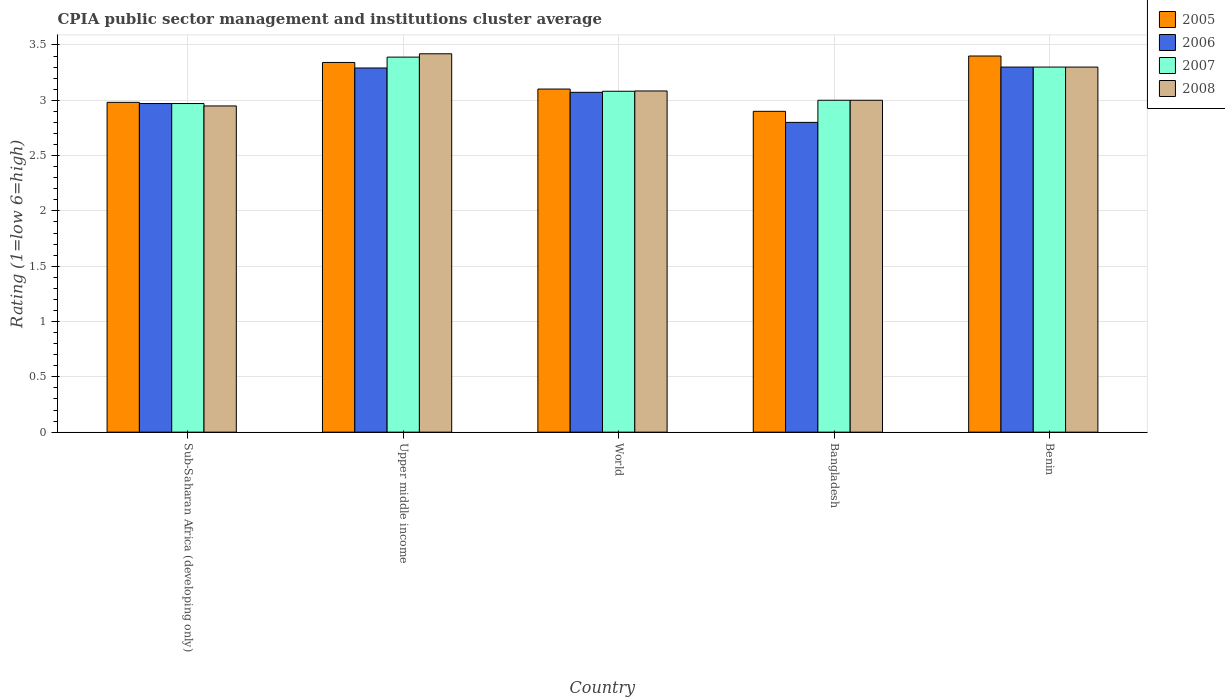How many different coloured bars are there?
Your response must be concise. 4. How many groups of bars are there?
Provide a short and direct response. 5. How many bars are there on the 3rd tick from the right?
Offer a terse response. 4. What is the label of the 5th group of bars from the left?
Offer a terse response. Benin. What is the CPIA rating in 2007 in Upper middle income?
Offer a terse response. 3.39. Across all countries, what is the minimum CPIA rating in 2007?
Ensure brevity in your answer.  2.97. In which country was the CPIA rating in 2005 maximum?
Provide a short and direct response. Benin. In which country was the CPIA rating in 2008 minimum?
Provide a short and direct response. Sub-Saharan Africa (developing only). What is the total CPIA rating in 2007 in the graph?
Provide a succinct answer. 15.74. What is the difference between the CPIA rating in 2006 in Benin and that in World?
Make the answer very short. 0.23. What is the difference between the CPIA rating in 2007 in World and the CPIA rating in 2005 in Benin?
Provide a short and direct response. -0.32. What is the average CPIA rating in 2006 per country?
Keep it short and to the point. 3.09. What is the difference between the CPIA rating of/in 2006 and CPIA rating of/in 2008 in Benin?
Provide a short and direct response. 0. In how many countries, is the CPIA rating in 2006 greater than 0.6?
Keep it short and to the point. 5. What is the ratio of the CPIA rating in 2006 in Benin to that in Sub-Saharan Africa (developing only)?
Provide a succinct answer. 1.11. What is the difference between the highest and the second highest CPIA rating in 2006?
Give a very brief answer. -0.01. Is it the case that in every country, the sum of the CPIA rating in 2005 and CPIA rating in 2007 is greater than the sum of CPIA rating in 2008 and CPIA rating in 2006?
Your response must be concise. No. What does the 2nd bar from the right in Sub-Saharan Africa (developing only) represents?
Provide a succinct answer. 2007. Is it the case that in every country, the sum of the CPIA rating in 2007 and CPIA rating in 2008 is greater than the CPIA rating in 2005?
Provide a succinct answer. Yes. How many countries are there in the graph?
Give a very brief answer. 5. Does the graph contain any zero values?
Your answer should be compact. No. Where does the legend appear in the graph?
Give a very brief answer. Top right. How many legend labels are there?
Your response must be concise. 4. What is the title of the graph?
Your answer should be compact. CPIA public sector management and institutions cluster average. Does "1997" appear as one of the legend labels in the graph?
Your answer should be very brief. No. What is the label or title of the Y-axis?
Keep it short and to the point. Rating (1=low 6=high). What is the Rating (1=low 6=high) in 2005 in Sub-Saharan Africa (developing only)?
Your response must be concise. 2.98. What is the Rating (1=low 6=high) in 2006 in Sub-Saharan Africa (developing only)?
Your response must be concise. 2.97. What is the Rating (1=low 6=high) in 2007 in Sub-Saharan Africa (developing only)?
Your response must be concise. 2.97. What is the Rating (1=low 6=high) of 2008 in Sub-Saharan Africa (developing only)?
Keep it short and to the point. 2.95. What is the Rating (1=low 6=high) in 2005 in Upper middle income?
Offer a terse response. 3.34. What is the Rating (1=low 6=high) of 2006 in Upper middle income?
Give a very brief answer. 3.29. What is the Rating (1=low 6=high) of 2007 in Upper middle income?
Offer a terse response. 3.39. What is the Rating (1=low 6=high) in 2008 in Upper middle income?
Your response must be concise. 3.42. What is the Rating (1=low 6=high) of 2005 in World?
Offer a terse response. 3.1. What is the Rating (1=low 6=high) of 2006 in World?
Offer a terse response. 3.07. What is the Rating (1=low 6=high) in 2007 in World?
Give a very brief answer. 3.08. What is the Rating (1=low 6=high) of 2008 in World?
Offer a terse response. 3.08. What is the Rating (1=low 6=high) in 2005 in Bangladesh?
Provide a succinct answer. 2.9. What is the Rating (1=low 6=high) in 2005 in Benin?
Ensure brevity in your answer.  3.4. What is the Rating (1=low 6=high) in 2008 in Benin?
Your response must be concise. 3.3. Across all countries, what is the maximum Rating (1=low 6=high) of 2007?
Your answer should be very brief. 3.39. Across all countries, what is the maximum Rating (1=low 6=high) of 2008?
Give a very brief answer. 3.42. Across all countries, what is the minimum Rating (1=low 6=high) of 2005?
Offer a very short reply. 2.9. Across all countries, what is the minimum Rating (1=low 6=high) of 2006?
Your answer should be compact. 2.8. Across all countries, what is the minimum Rating (1=low 6=high) of 2007?
Ensure brevity in your answer.  2.97. Across all countries, what is the minimum Rating (1=low 6=high) in 2008?
Make the answer very short. 2.95. What is the total Rating (1=low 6=high) in 2005 in the graph?
Your answer should be compact. 15.72. What is the total Rating (1=low 6=high) of 2006 in the graph?
Provide a succinct answer. 15.43. What is the total Rating (1=low 6=high) of 2007 in the graph?
Keep it short and to the point. 15.74. What is the total Rating (1=low 6=high) of 2008 in the graph?
Keep it short and to the point. 15.75. What is the difference between the Rating (1=low 6=high) of 2005 in Sub-Saharan Africa (developing only) and that in Upper middle income?
Provide a succinct answer. -0.36. What is the difference between the Rating (1=low 6=high) in 2006 in Sub-Saharan Africa (developing only) and that in Upper middle income?
Make the answer very short. -0.32. What is the difference between the Rating (1=low 6=high) in 2007 in Sub-Saharan Africa (developing only) and that in Upper middle income?
Your response must be concise. -0.42. What is the difference between the Rating (1=low 6=high) of 2008 in Sub-Saharan Africa (developing only) and that in Upper middle income?
Keep it short and to the point. -0.47. What is the difference between the Rating (1=low 6=high) in 2005 in Sub-Saharan Africa (developing only) and that in World?
Your answer should be compact. -0.12. What is the difference between the Rating (1=low 6=high) in 2006 in Sub-Saharan Africa (developing only) and that in World?
Offer a very short reply. -0.1. What is the difference between the Rating (1=low 6=high) in 2007 in Sub-Saharan Africa (developing only) and that in World?
Offer a terse response. -0.11. What is the difference between the Rating (1=low 6=high) in 2008 in Sub-Saharan Africa (developing only) and that in World?
Your answer should be compact. -0.14. What is the difference between the Rating (1=low 6=high) of 2005 in Sub-Saharan Africa (developing only) and that in Bangladesh?
Offer a very short reply. 0.08. What is the difference between the Rating (1=low 6=high) in 2006 in Sub-Saharan Africa (developing only) and that in Bangladesh?
Provide a short and direct response. 0.17. What is the difference between the Rating (1=low 6=high) of 2007 in Sub-Saharan Africa (developing only) and that in Bangladesh?
Keep it short and to the point. -0.03. What is the difference between the Rating (1=low 6=high) in 2008 in Sub-Saharan Africa (developing only) and that in Bangladesh?
Provide a succinct answer. -0.05. What is the difference between the Rating (1=low 6=high) in 2005 in Sub-Saharan Africa (developing only) and that in Benin?
Your answer should be very brief. -0.42. What is the difference between the Rating (1=low 6=high) of 2006 in Sub-Saharan Africa (developing only) and that in Benin?
Give a very brief answer. -0.33. What is the difference between the Rating (1=low 6=high) in 2007 in Sub-Saharan Africa (developing only) and that in Benin?
Keep it short and to the point. -0.33. What is the difference between the Rating (1=low 6=high) of 2008 in Sub-Saharan Africa (developing only) and that in Benin?
Provide a short and direct response. -0.35. What is the difference between the Rating (1=low 6=high) of 2005 in Upper middle income and that in World?
Make the answer very short. 0.24. What is the difference between the Rating (1=low 6=high) in 2006 in Upper middle income and that in World?
Give a very brief answer. 0.22. What is the difference between the Rating (1=low 6=high) of 2007 in Upper middle income and that in World?
Your answer should be very brief. 0.31. What is the difference between the Rating (1=low 6=high) of 2008 in Upper middle income and that in World?
Offer a very short reply. 0.34. What is the difference between the Rating (1=low 6=high) of 2005 in Upper middle income and that in Bangladesh?
Give a very brief answer. 0.44. What is the difference between the Rating (1=low 6=high) in 2006 in Upper middle income and that in Bangladesh?
Give a very brief answer. 0.49. What is the difference between the Rating (1=low 6=high) of 2007 in Upper middle income and that in Bangladesh?
Ensure brevity in your answer.  0.39. What is the difference between the Rating (1=low 6=high) of 2008 in Upper middle income and that in Bangladesh?
Provide a short and direct response. 0.42. What is the difference between the Rating (1=low 6=high) of 2005 in Upper middle income and that in Benin?
Offer a terse response. -0.06. What is the difference between the Rating (1=low 6=high) of 2006 in Upper middle income and that in Benin?
Your response must be concise. -0.01. What is the difference between the Rating (1=low 6=high) in 2007 in Upper middle income and that in Benin?
Provide a succinct answer. 0.09. What is the difference between the Rating (1=low 6=high) of 2008 in Upper middle income and that in Benin?
Your answer should be compact. 0.12. What is the difference between the Rating (1=low 6=high) in 2005 in World and that in Bangladesh?
Provide a succinct answer. 0.2. What is the difference between the Rating (1=low 6=high) of 2006 in World and that in Bangladesh?
Make the answer very short. 0.27. What is the difference between the Rating (1=low 6=high) in 2007 in World and that in Bangladesh?
Provide a succinct answer. 0.08. What is the difference between the Rating (1=low 6=high) of 2008 in World and that in Bangladesh?
Your answer should be very brief. 0.08. What is the difference between the Rating (1=low 6=high) of 2005 in World and that in Benin?
Ensure brevity in your answer.  -0.3. What is the difference between the Rating (1=low 6=high) in 2006 in World and that in Benin?
Your response must be concise. -0.23. What is the difference between the Rating (1=low 6=high) in 2007 in World and that in Benin?
Offer a very short reply. -0.22. What is the difference between the Rating (1=low 6=high) in 2008 in World and that in Benin?
Your answer should be very brief. -0.22. What is the difference between the Rating (1=low 6=high) in 2006 in Bangladesh and that in Benin?
Make the answer very short. -0.5. What is the difference between the Rating (1=low 6=high) of 2007 in Bangladesh and that in Benin?
Provide a short and direct response. -0.3. What is the difference between the Rating (1=low 6=high) in 2008 in Bangladesh and that in Benin?
Provide a short and direct response. -0.3. What is the difference between the Rating (1=low 6=high) of 2005 in Sub-Saharan Africa (developing only) and the Rating (1=low 6=high) of 2006 in Upper middle income?
Provide a short and direct response. -0.31. What is the difference between the Rating (1=low 6=high) of 2005 in Sub-Saharan Africa (developing only) and the Rating (1=low 6=high) of 2007 in Upper middle income?
Ensure brevity in your answer.  -0.41. What is the difference between the Rating (1=low 6=high) in 2005 in Sub-Saharan Africa (developing only) and the Rating (1=low 6=high) in 2008 in Upper middle income?
Provide a succinct answer. -0.44. What is the difference between the Rating (1=low 6=high) in 2006 in Sub-Saharan Africa (developing only) and the Rating (1=low 6=high) in 2007 in Upper middle income?
Your answer should be very brief. -0.42. What is the difference between the Rating (1=low 6=high) in 2006 in Sub-Saharan Africa (developing only) and the Rating (1=low 6=high) in 2008 in Upper middle income?
Offer a terse response. -0.45. What is the difference between the Rating (1=low 6=high) of 2007 in Sub-Saharan Africa (developing only) and the Rating (1=low 6=high) of 2008 in Upper middle income?
Your answer should be very brief. -0.45. What is the difference between the Rating (1=low 6=high) of 2005 in Sub-Saharan Africa (developing only) and the Rating (1=low 6=high) of 2006 in World?
Keep it short and to the point. -0.09. What is the difference between the Rating (1=low 6=high) in 2005 in Sub-Saharan Africa (developing only) and the Rating (1=low 6=high) in 2007 in World?
Ensure brevity in your answer.  -0.1. What is the difference between the Rating (1=low 6=high) in 2005 in Sub-Saharan Africa (developing only) and the Rating (1=low 6=high) in 2008 in World?
Offer a very short reply. -0.1. What is the difference between the Rating (1=low 6=high) of 2006 in Sub-Saharan Africa (developing only) and the Rating (1=low 6=high) of 2007 in World?
Your answer should be compact. -0.11. What is the difference between the Rating (1=low 6=high) in 2006 in Sub-Saharan Africa (developing only) and the Rating (1=low 6=high) in 2008 in World?
Offer a very short reply. -0.11. What is the difference between the Rating (1=low 6=high) in 2007 in Sub-Saharan Africa (developing only) and the Rating (1=low 6=high) in 2008 in World?
Provide a succinct answer. -0.11. What is the difference between the Rating (1=low 6=high) in 2005 in Sub-Saharan Africa (developing only) and the Rating (1=low 6=high) in 2006 in Bangladesh?
Keep it short and to the point. 0.18. What is the difference between the Rating (1=low 6=high) of 2005 in Sub-Saharan Africa (developing only) and the Rating (1=low 6=high) of 2007 in Bangladesh?
Your answer should be compact. -0.02. What is the difference between the Rating (1=low 6=high) in 2005 in Sub-Saharan Africa (developing only) and the Rating (1=low 6=high) in 2008 in Bangladesh?
Provide a short and direct response. -0.02. What is the difference between the Rating (1=low 6=high) of 2006 in Sub-Saharan Africa (developing only) and the Rating (1=low 6=high) of 2007 in Bangladesh?
Ensure brevity in your answer.  -0.03. What is the difference between the Rating (1=low 6=high) in 2006 in Sub-Saharan Africa (developing only) and the Rating (1=low 6=high) in 2008 in Bangladesh?
Your answer should be compact. -0.03. What is the difference between the Rating (1=low 6=high) of 2007 in Sub-Saharan Africa (developing only) and the Rating (1=low 6=high) of 2008 in Bangladesh?
Your answer should be compact. -0.03. What is the difference between the Rating (1=low 6=high) of 2005 in Sub-Saharan Africa (developing only) and the Rating (1=low 6=high) of 2006 in Benin?
Ensure brevity in your answer.  -0.32. What is the difference between the Rating (1=low 6=high) in 2005 in Sub-Saharan Africa (developing only) and the Rating (1=low 6=high) in 2007 in Benin?
Ensure brevity in your answer.  -0.32. What is the difference between the Rating (1=low 6=high) of 2005 in Sub-Saharan Africa (developing only) and the Rating (1=low 6=high) of 2008 in Benin?
Your answer should be compact. -0.32. What is the difference between the Rating (1=low 6=high) in 2006 in Sub-Saharan Africa (developing only) and the Rating (1=low 6=high) in 2007 in Benin?
Your response must be concise. -0.33. What is the difference between the Rating (1=low 6=high) in 2006 in Sub-Saharan Africa (developing only) and the Rating (1=low 6=high) in 2008 in Benin?
Your answer should be compact. -0.33. What is the difference between the Rating (1=low 6=high) of 2007 in Sub-Saharan Africa (developing only) and the Rating (1=low 6=high) of 2008 in Benin?
Your response must be concise. -0.33. What is the difference between the Rating (1=low 6=high) in 2005 in Upper middle income and the Rating (1=low 6=high) in 2006 in World?
Provide a succinct answer. 0.27. What is the difference between the Rating (1=low 6=high) in 2005 in Upper middle income and the Rating (1=low 6=high) in 2007 in World?
Make the answer very short. 0.26. What is the difference between the Rating (1=low 6=high) in 2005 in Upper middle income and the Rating (1=low 6=high) in 2008 in World?
Offer a very short reply. 0.26. What is the difference between the Rating (1=low 6=high) in 2006 in Upper middle income and the Rating (1=low 6=high) in 2007 in World?
Give a very brief answer. 0.21. What is the difference between the Rating (1=low 6=high) of 2006 in Upper middle income and the Rating (1=low 6=high) of 2008 in World?
Your response must be concise. 0.21. What is the difference between the Rating (1=low 6=high) of 2007 in Upper middle income and the Rating (1=low 6=high) of 2008 in World?
Offer a terse response. 0.31. What is the difference between the Rating (1=low 6=high) of 2005 in Upper middle income and the Rating (1=low 6=high) of 2006 in Bangladesh?
Your answer should be compact. 0.54. What is the difference between the Rating (1=low 6=high) in 2005 in Upper middle income and the Rating (1=low 6=high) in 2007 in Bangladesh?
Ensure brevity in your answer.  0.34. What is the difference between the Rating (1=low 6=high) in 2005 in Upper middle income and the Rating (1=low 6=high) in 2008 in Bangladesh?
Ensure brevity in your answer.  0.34. What is the difference between the Rating (1=low 6=high) in 2006 in Upper middle income and the Rating (1=low 6=high) in 2007 in Bangladesh?
Provide a succinct answer. 0.29. What is the difference between the Rating (1=low 6=high) in 2006 in Upper middle income and the Rating (1=low 6=high) in 2008 in Bangladesh?
Offer a very short reply. 0.29. What is the difference between the Rating (1=low 6=high) of 2007 in Upper middle income and the Rating (1=low 6=high) of 2008 in Bangladesh?
Keep it short and to the point. 0.39. What is the difference between the Rating (1=low 6=high) of 2005 in Upper middle income and the Rating (1=low 6=high) of 2006 in Benin?
Ensure brevity in your answer.  0.04. What is the difference between the Rating (1=low 6=high) in 2005 in Upper middle income and the Rating (1=low 6=high) in 2007 in Benin?
Ensure brevity in your answer.  0.04. What is the difference between the Rating (1=low 6=high) of 2005 in Upper middle income and the Rating (1=low 6=high) of 2008 in Benin?
Make the answer very short. 0.04. What is the difference between the Rating (1=low 6=high) in 2006 in Upper middle income and the Rating (1=low 6=high) in 2007 in Benin?
Ensure brevity in your answer.  -0.01. What is the difference between the Rating (1=low 6=high) in 2006 in Upper middle income and the Rating (1=low 6=high) in 2008 in Benin?
Your response must be concise. -0.01. What is the difference between the Rating (1=low 6=high) in 2007 in Upper middle income and the Rating (1=low 6=high) in 2008 in Benin?
Your answer should be compact. 0.09. What is the difference between the Rating (1=low 6=high) in 2005 in World and the Rating (1=low 6=high) in 2006 in Bangladesh?
Offer a terse response. 0.3. What is the difference between the Rating (1=low 6=high) of 2005 in World and the Rating (1=low 6=high) of 2007 in Bangladesh?
Provide a short and direct response. 0.1. What is the difference between the Rating (1=low 6=high) in 2005 in World and the Rating (1=low 6=high) in 2008 in Bangladesh?
Your response must be concise. 0.1. What is the difference between the Rating (1=low 6=high) in 2006 in World and the Rating (1=low 6=high) in 2007 in Bangladesh?
Your answer should be compact. 0.07. What is the difference between the Rating (1=low 6=high) in 2006 in World and the Rating (1=low 6=high) in 2008 in Bangladesh?
Your answer should be compact. 0.07. What is the difference between the Rating (1=low 6=high) in 2007 in World and the Rating (1=low 6=high) in 2008 in Bangladesh?
Make the answer very short. 0.08. What is the difference between the Rating (1=low 6=high) in 2005 in World and the Rating (1=low 6=high) in 2006 in Benin?
Make the answer very short. -0.2. What is the difference between the Rating (1=low 6=high) in 2005 in World and the Rating (1=low 6=high) in 2007 in Benin?
Your answer should be compact. -0.2. What is the difference between the Rating (1=low 6=high) of 2005 in World and the Rating (1=low 6=high) of 2008 in Benin?
Provide a succinct answer. -0.2. What is the difference between the Rating (1=low 6=high) in 2006 in World and the Rating (1=low 6=high) in 2007 in Benin?
Your response must be concise. -0.23. What is the difference between the Rating (1=low 6=high) in 2006 in World and the Rating (1=low 6=high) in 2008 in Benin?
Keep it short and to the point. -0.23. What is the difference between the Rating (1=low 6=high) of 2007 in World and the Rating (1=low 6=high) of 2008 in Benin?
Offer a terse response. -0.22. What is the difference between the Rating (1=low 6=high) of 2006 in Bangladesh and the Rating (1=low 6=high) of 2007 in Benin?
Offer a very short reply. -0.5. What is the difference between the Rating (1=low 6=high) of 2007 in Bangladesh and the Rating (1=low 6=high) of 2008 in Benin?
Keep it short and to the point. -0.3. What is the average Rating (1=low 6=high) of 2005 per country?
Give a very brief answer. 3.14. What is the average Rating (1=low 6=high) in 2006 per country?
Your response must be concise. 3.09. What is the average Rating (1=low 6=high) in 2007 per country?
Provide a short and direct response. 3.15. What is the average Rating (1=low 6=high) in 2008 per country?
Keep it short and to the point. 3.15. What is the difference between the Rating (1=low 6=high) of 2005 and Rating (1=low 6=high) of 2006 in Sub-Saharan Africa (developing only)?
Provide a succinct answer. 0.01. What is the difference between the Rating (1=low 6=high) in 2005 and Rating (1=low 6=high) in 2007 in Sub-Saharan Africa (developing only)?
Offer a very short reply. 0.01. What is the difference between the Rating (1=low 6=high) of 2005 and Rating (1=low 6=high) of 2008 in Sub-Saharan Africa (developing only)?
Offer a terse response. 0.03. What is the difference between the Rating (1=low 6=high) of 2006 and Rating (1=low 6=high) of 2007 in Sub-Saharan Africa (developing only)?
Make the answer very short. 0. What is the difference between the Rating (1=low 6=high) in 2006 and Rating (1=low 6=high) in 2008 in Sub-Saharan Africa (developing only)?
Your answer should be compact. 0.02. What is the difference between the Rating (1=low 6=high) in 2007 and Rating (1=low 6=high) in 2008 in Sub-Saharan Africa (developing only)?
Give a very brief answer. 0.02. What is the difference between the Rating (1=low 6=high) of 2005 and Rating (1=low 6=high) of 2006 in Upper middle income?
Make the answer very short. 0.05. What is the difference between the Rating (1=low 6=high) of 2005 and Rating (1=low 6=high) of 2007 in Upper middle income?
Your answer should be very brief. -0.05. What is the difference between the Rating (1=low 6=high) of 2005 and Rating (1=low 6=high) of 2008 in Upper middle income?
Offer a very short reply. -0.08. What is the difference between the Rating (1=low 6=high) in 2006 and Rating (1=low 6=high) in 2007 in Upper middle income?
Make the answer very short. -0.1. What is the difference between the Rating (1=low 6=high) of 2006 and Rating (1=low 6=high) of 2008 in Upper middle income?
Offer a terse response. -0.13. What is the difference between the Rating (1=low 6=high) of 2007 and Rating (1=low 6=high) of 2008 in Upper middle income?
Provide a short and direct response. -0.03. What is the difference between the Rating (1=low 6=high) in 2005 and Rating (1=low 6=high) in 2006 in World?
Your answer should be very brief. 0.03. What is the difference between the Rating (1=low 6=high) in 2005 and Rating (1=low 6=high) in 2008 in World?
Keep it short and to the point. 0.02. What is the difference between the Rating (1=low 6=high) in 2006 and Rating (1=low 6=high) in 2007 in World?
Make the answer very short. -0.01. What is the difference between the Rating (1=low 6=high) of 2006 and Rating (1=low 6=high) of 2008 in World?
Your answer should be very brief. -0.01. What is the difference between the Rating (1=low 6=high) of 2007 and Rating (1=low 6=high) of 2008 in World?
Ensure brevity in your answer.  -0. What is the difference between the Rating (1=low 6=high) of 2006 and Rating (1=low 6=high) of 2008 in Bangladesh?
Your response must be concise. -0.2. What is the difference between the Rating (1=low 6=high) in 2007 and Rating (1=low 6=high) in 2008 in Bangladesh?
Keep it short and to the point. 0. What is the difference between the Rating (1=low 6=high) in 2005 and Rating (1=low 6=high) in 2006 in Benin?
Make the answer very short. 0.1. What is the ratio of the Rating (1=low 6=high) of 2005 in Sub-Saharan Africa (developing only) to that in Upper middle income?
Provide a short and direct response. 0.89. What is the ratio of the Rating (1=low 6=high) of 2006 in Sub-Saharan Africa (developing only) to that in Upper middle income?
Ensure brevity in your answer.  0.9. What is the ratio of the Rating (1=low 6=high) in 2007 in Sub-Saharan Africa (developing only) to that in Upper middle income?
Make the answer very short. 0.88. What is the ratio of the Rating (1=low 6=high) in 2008 in Sub-Saharan Africa (developing only) to that in Upper middle income?
Provide a succinct answer. 0.86. What is the ratio of the Rating (1=low 6=high) in 2005 in Sub-Saharan Africa (developing only) to that in World?
Make the answer very short. 0.96. What is the ratio of the Rating (1=low 6=high) of 2006 in Sub-Saharan Africa (developing only) to that in World?
Your answer should be compact. 0.97. What is the ratio of the Rating (1=low 6=high) of 2007 in Sub-Saharan Africa (developing only) to that in World?
Offer a terse response. 0.96. What is the ratio of the Rating (1=low 6=high) in 2008 in Sub-Saharan Africa (developing only) to that in World?
Make the answer very short. 0.96. What is the ratio of the Rating (1=low 6=high) in 2005 in Sub-Saharan Africa (developing only) to that in Bangladesh?
Make the answer very short. 1.03. What is the ratio of the Rating (1=low 6=high) in 2006 in Sub-Saharan Africa (developing only) to that in Bangladesh?
Give a very brief answer. 1.06. What is the ratio of the Rating (1=low 6=high) in 2007 in Sub-Saharan Africa (developing only) to that in Bangladesh?
Keep it short and to the point. 0.99. What is the ratio of the Rating (1=low 6=high) in 2008 in Sub-Saharan Africa (developing only) to that in Bangladesh?
Provide a short and direct response. 0.98. What is the ratio of the Rating (1=low 6=high) in 2005 in Sub-Saharan Africa (developing only) to that in Benin?
Keep it short and to the point. 0.88. What is the ratio of the Rating (1=low 6=high) in 2006 in Sub-Saharan Africa (developing only) to that in Benin?
Provide a succinct answer. 0.9. What is the ratio of the Rating (1=low 6=high) in 2007 in Sub-Saharan Africa (developing only) to that in Benin?
Your answer should be compact. 0.9. What is the ratio of the Rating (1=low 6=high) of 2008 in Sub-Saharan Africa (developing only) to that in Benin?
Make the answer very short. 0.89. What is the ratio of the Rating (1=low 6=high) in 2005 in Upper middle income to that in World?
Provide a short and direct response. 1.08. What is the ratio of the Rating (1=low 6=high) of 2006 in Upper middle income to that in World?
Your response must be concise. 1.07. What is the ratio of the Rating (1=low 6=high) in 2007 in Upper middle income to that in World?
Your response must be concise. 1.1. What is the ratio of the Rating (1=low 6=high) of 2008 in Upper middle income to that in World?
Your answer should be compact. 1.11. What is the ratio of the Rating (1=low 6=high) in 2005 in Upper middle income to that in Bangladesh?
Your response must be concise. 1.15. What is the ratio of the Rating (1=low 6=high) in 2006 in Upper middle income to that in Bangladesh?
Give a very brief answer. 1.18. What is the ratio of the Rating (1=low 6=high) of 2007 in Upper middle income to that in Bangladesh?
Offer a very short reply. 1.13. What is the ratio of the Rating (1=low 6=high) of 2008 in Upper middle income to that in Bangladesh?
Offer a very short reply. 1.14. What is the ratio of the Rating (1=low 6=high) of 2005 in Upper middle income to that in Benin?
Your answer should be very brief. 0.98. What is the ratio of the Rating (1=low 6=high) of 2006 in Upper middle income to that in Benin?
Provide a short and direct response. 1. What is the ratio of the Rating (1=low 6=high) in 2007 in Upper middle income to that in Benin?
Offer a terse response. 1.03. What is the ratio of the Rating (1=low 6=high) of 2008 in Upper middle income to that in Benin?
Ensure brevity in your answer.  1.04. What is the ratio of the Rating (1=low 6=high) of 2005 in World to that in Bangladesh?
Provide a short and direct response. 1.07. What is the ratio of the Rating (1=low 6=high) of 2006 in World to that in Bangladesh?
Your response must be concise. 1.1. What is the ratio of the Rating (1=low 6=high) in 2007 in World to that in Bangladesh?
Your answer should be compact. 1.03. What is the ratio of the Rating (1=low 6=high) in 2008 in World to that in Bangladesh?
Your answer should be very brief. 1.03. What is the ratio of the Rating (1=low 6=high) of 2005 in World to that in Benin?
Provide a succinct answer. 0.91. What is the ratio of the Rating (1=low 6=high) in 2006 in World to that in Benin?
Your answer should be compact. 0.93. What is the ratio of the Rating (1=low 6=high) of 2007 in World to that in Benin?
Your answer should be very brief. 0.93. What is the ratio of the Rating (1=low 6=high) of 2008 in World to that in Benin?
Provide a short and direct response. 0.93. What is the ratio of the Rating (1=low 6=high) of 2005 in Bangladesh to that in Benin?
Keep it short and to the point. 0.85. What is the ratio of the Rating (1=low 6=high) in 2006 in Bangladesh to that in Benin?
Keep it short and to the point. 0.85. What is the ratio of the Rating (1=low 6=high) in 2008 in Bangladesh to that in Benin?
Provide a succinct answer. 0.91. What is the difference between the highest and the second highest Rating (1=low 6=high) of 2005?
Offer a very short reply. 0.06. What is the difference between the highest and the second highest Rating (1=low 6=high) in 2006?
Ensure brevity in your answer.  0.01. What is the difference between the highest and the second highest Rating (1=low 6=high) in 2007?
Keep it short and to the point. 0.09. What is the difference between the highest and the second highest Rating (1=low 6=high) of 2008?
Your answer should be very brief. 0.12. What is the difference between the highest and the lowest Rating (1=low 6=high) in 2007?
Your answer should be compact. 0.42. What is the difference between the highest and the lowest Rating (1=low 6=high) in 2008?
Your response must be concise. 0.47. 